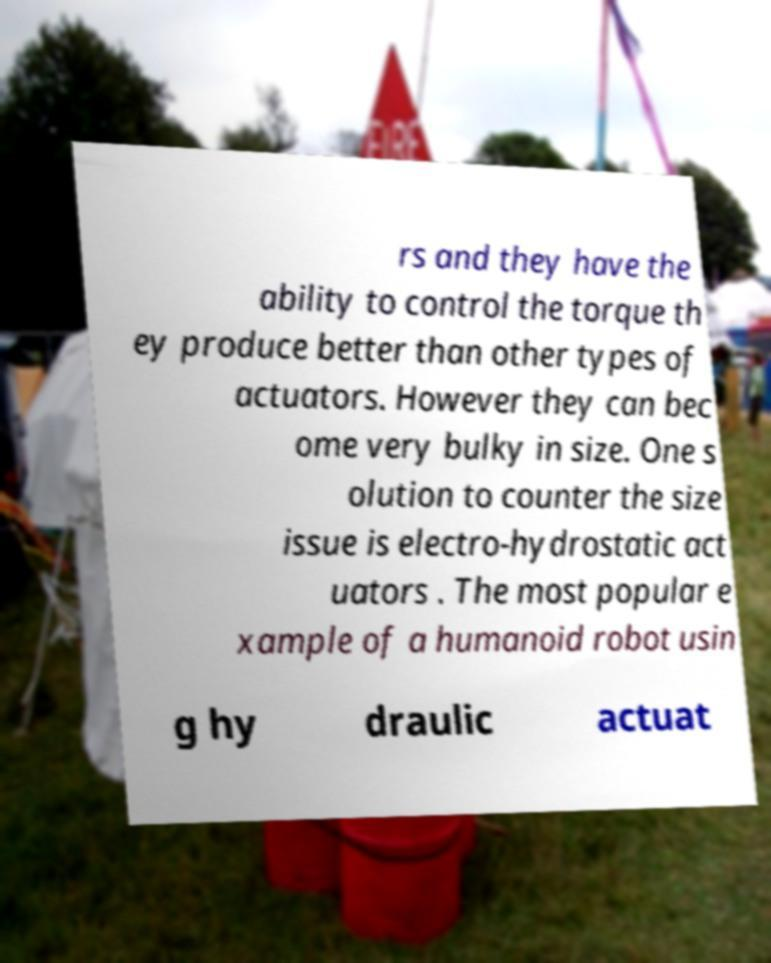Please read and relay the text visible in this image. What does it say? rs and they have the ability to control the torque th ey produce better than other types of actuators. However they can bec ome very bulky in size. One s olution to counter the size issue is electro-hydrostatic act uators . The most popular e xample of a humanoid robot usin g hy draulic actuat 